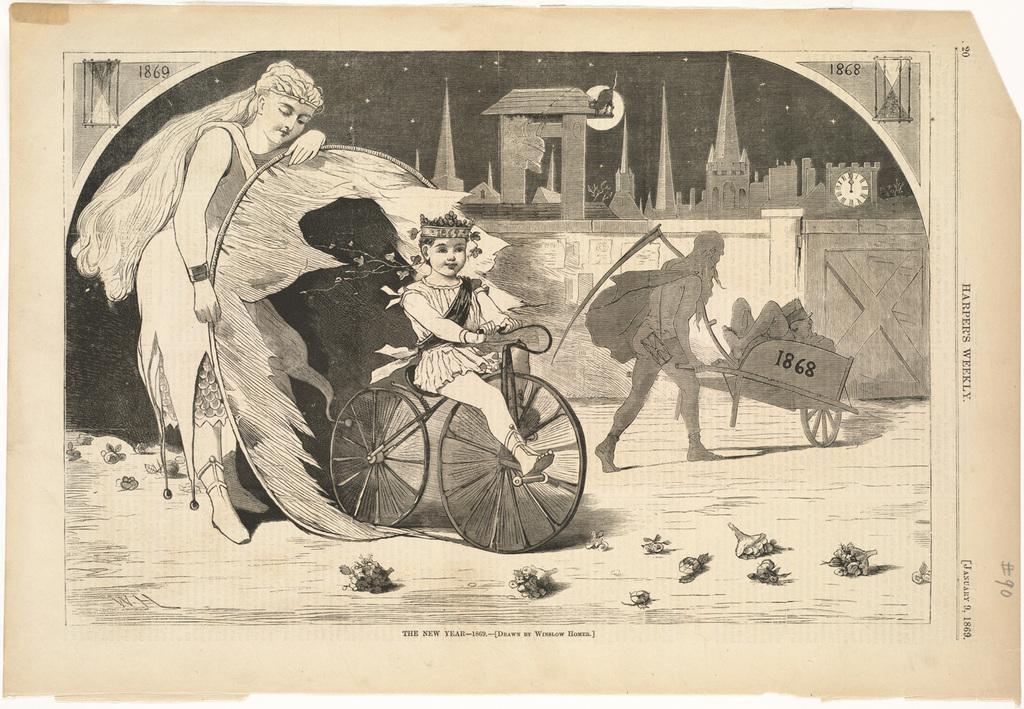Can you describe this image briefly? In this picture I can see a paper, there are numbers, words, there is an image of few people, there are buildings, clock and some other objects on the paper. 